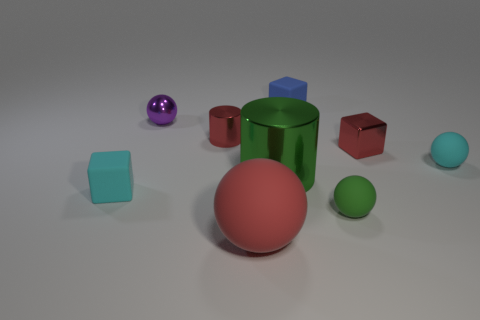Subtract all tiny rubber cubes. How many cubes are left? 1 Add 1 big matte spheres. How many objects exist? 10 Subtract all red cylinders. How many cylinders are left? 1 Subtract all cubes. How many objects are left? 6 Subtract 1 cylinders. How many cylinders are left? 1 Subtract all blue spheres. Subtract all red blocks. How many spheres are left? 4 Subtract all green blocks. How many cyan balls are left? 1 Subtract all green spheres. Subtract all tiny cylinders. How many objects are left? 7 Add 2 metal cubes. How many metal cubes are left? 3 Add 7 small yellow rubber spheres. How many small yellow rubber spheres exist? 7 